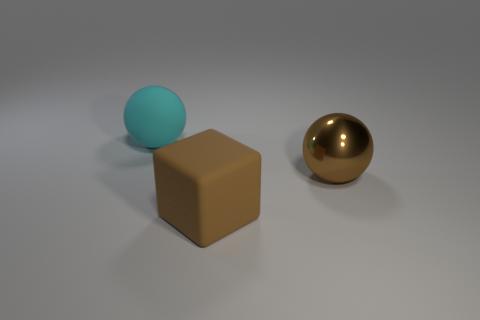Subtract all cyan balls. How many balls are left? 1 Subtract all brown spheres. Subtract all brown cubes. How many spheres are left? 1 Subtract all gray cylinders. How many brown spheres are left? 1 Subtract all brown cubes. Subtract all brown metallic balls. How many objects are left? 1 Add 1 cyan balls. How many cyan balls are left? 2 Add 1 blocks. How many blocks exist? 2 Add 3 cyan objects. How many objects exist? 6 Subtract 0 green spheres. How many objects are left? 3 Subtract all balls. How many objects are left? 1 Subtract 2 spheres. How many spheres are left? 0 